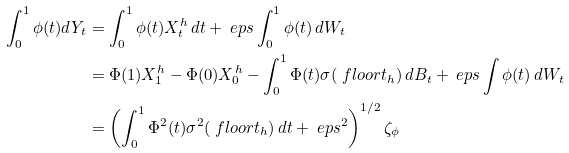<formula> <loc_0><loc_0><loc_500><loc_500>\int _ { 0 } ^ { 1 } \phi ( t ) d Y _ { t } & = \int _ { 0 } ^ { 1 } \phi ( t ) X _ { t } ^ { h } \, d t + \ e p s \int _ { 0 } ^ { 1 } \phi ( t ) \, d W _ { t } \\ & = \Phi ( 1 ) X _ { 1 } ^ { h } - \Phi ( 0 ) X _ { 0 } ^ { h } - \int _ { 0 } ^ { 1 } \Phi ( t ) \sigma ( \ f l o o r { t } _ { h } ) \, d B _ { t } + \ e p s \int \phi ( t ) \, d W _ { t } \\ & = \left ( \int _ { 0 } ^ { 1 } \Phi ^ { 2 } ( t ) \sigma ^ { 2 } ( \ f l o o r { t } _ { h } ) \, d t + \ e p s ^ { 2 } \right ) ^ { 1 / 2 } \zeta _ { \phi }</formula> 